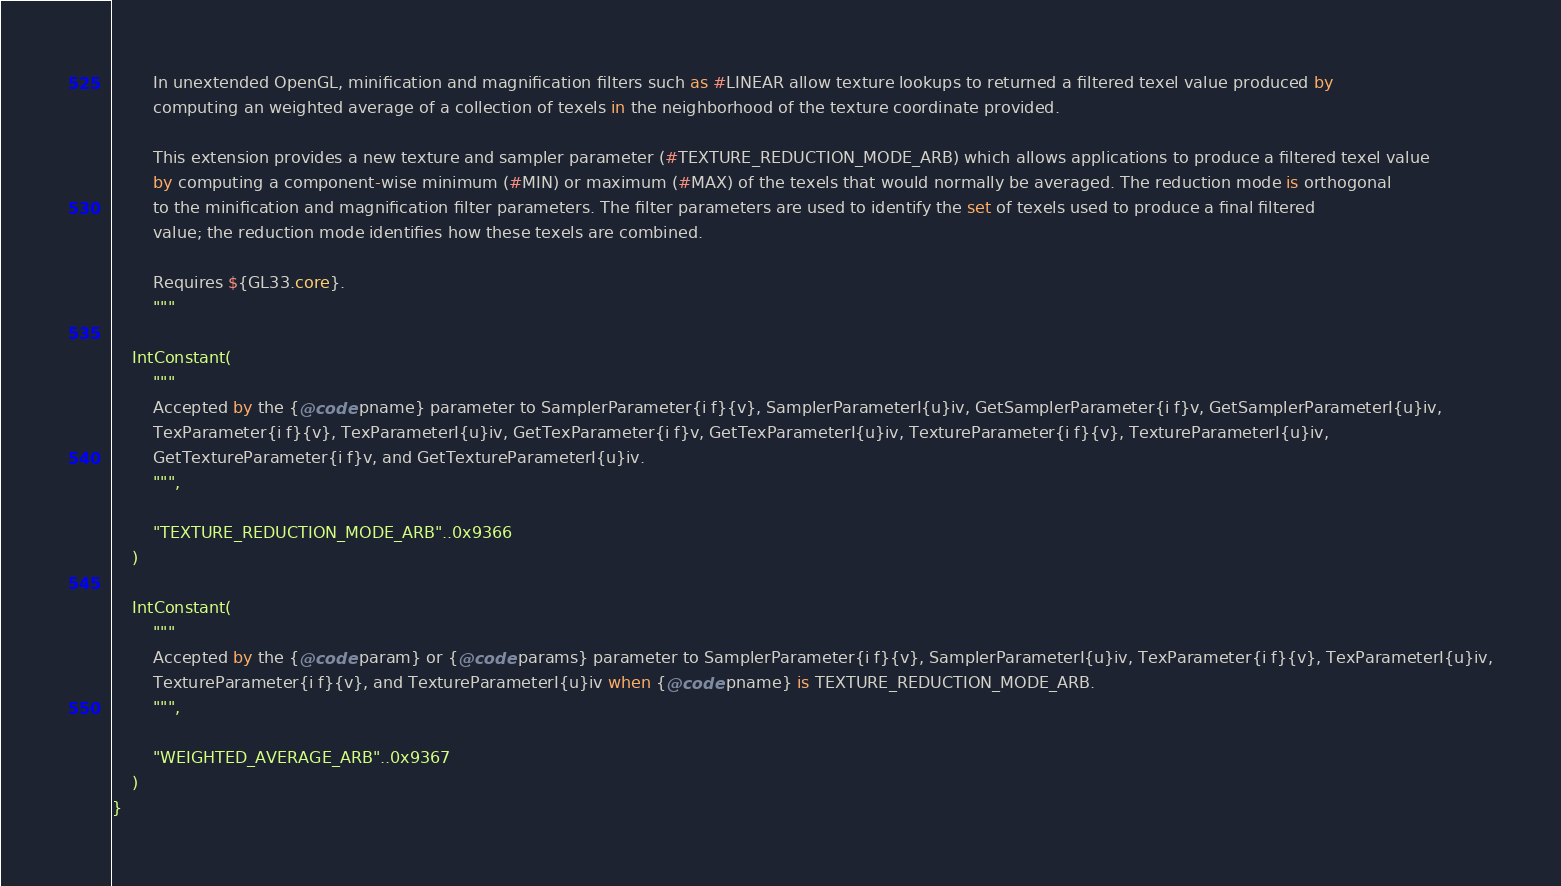<code> <loc_0><loc_0><loc_500><loc_500><_Kotlin_>
        In unextended OpenGL, minification and magnification filters such as #LINEAR allow texture lookups to returned a filtered texel value produced by
        computing an weighted average of a collection of texels in the neighborhood of the texture coordinate provided.

        This extension provides a new texture and sampler parameter (#TEXTURE_REDUCTION_MODE_ARB) which allows applications to produce a filtered texel value
        by computing a component-wise minimum (#MIN) or maximum (#MAX) of the texels that would normally be averaged. The reduction mode is orthogonal
        to the minification and magnification filter parameters. The filter parameters are used to identify the set of texels used to produce a final filtered
        value; the reduction mode identifies how these texels are combined.

        Requires ${GL33.core}.
        """

    IntConstant(
        """
        Accepted by the {@code pname} parameter to SamplerParameter{i f}{v}, SamplerParameterI{u}iv, GetSamplerParameter{i f}v, GetSamplerParameterI{u}iv,
        TexParameter{i f}{v}, TexParameterI{u}iv, GetTexParameter{i f}v, GetTexParameterI{u}iv, TextureParameter{i f}{v}, TextureParameterI{u}iv,
        GetTextureParameter{i f}v, and GetTextureParameterI{u}iv.
        """,

        "TEXTURE_REDUCTION_MODE_ARB"..0x9366
    )

    IntConstant(
        """
        Accepted by the {@code param} or {@code params} parameter to SamplerParameter{i f}{v}, SamplerParameterI{u}iv, TexParameter{i f}{v}, TexParameterI{u}iv,
        TextureParameter{i f}{v}, and TextureParameterI{u}iv when {@code pname} is TEXTURE_REDUCTION_MODE_ARB.
        """,

        "WEIGHTED_AVERAGE_ARB"..0x9367
    )
}</code> 